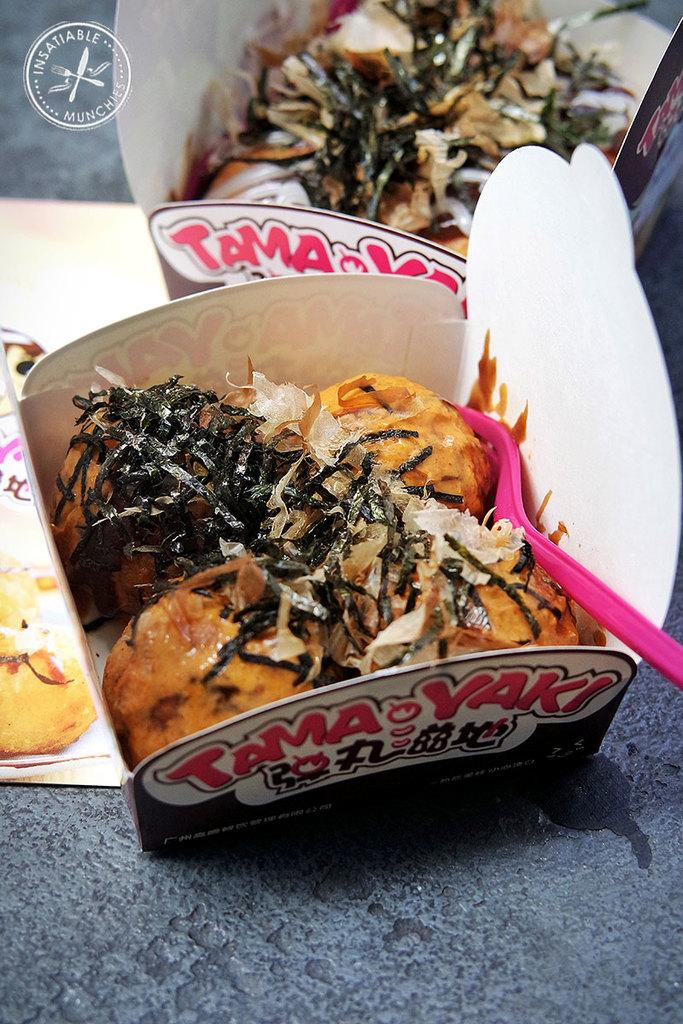What objects are present in the image? There are boxes in the image. What is inside the boxes? The boxes contain food. Where is the logo located in the image? The logo is in the top left of the image. What year does the scene in the image take place? The provided facts do not give any information about the year or time period in which the scene takes place. What is the profit margin of the food in the boxes? The provided facts do not give any information about the profit margin of the food in the boxes. 